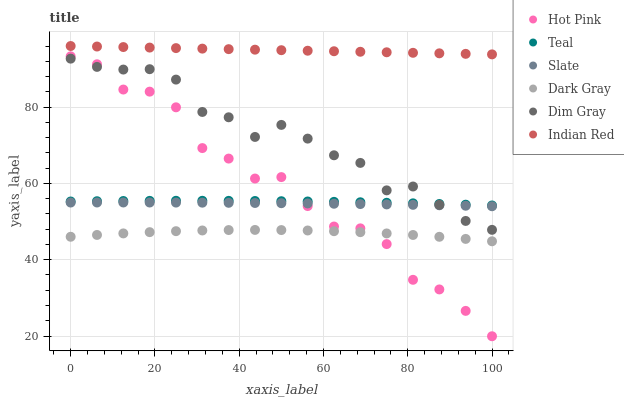Does Dark Gray have the minimum area under the curve?
Answer yes or no. Yes. Does Indian Red have the maximum area under the curve?
Answer yes or no. Yes. Does Teal have the minimum area under the curve?
Answer yes or no. No. Does Teal have the maximum area under the curve?
Answer yes or no. No. Is Indian Red the smoothest?
Answer yes or no. Yes. Is Hot Pink the roughest?
Answer yes or no. Yes. Is Teal the smoothest?
Answer yes or no. No. Is Teal the roughest?
Answer yes or no. No. Does Hot Pink have the lowest value?
Answer yes or no. Yes. Does Teal have the lowest value?
Answer yes or no. No. Does Indian Red have the highest value?
Answer yes or no. Yes. Does Teal have the highest value?
Answer yes or no. No. Is Dark Gray less than Dim Gray?
Answer yes or no. Yes. Is Indian Red greater than Slate?
Answer yes or no. Yes. Does Dark Gray intersect Hot Pink?
Answer yes or no. Yes. Is Dark Gray less than Hot Pink?
Answer yes or no. No. Is Dark Gray greater than Hot Pink?
Answer yes or no. No. Does Dark Gray intersect Dim Gray?
Answer yes or no. No. 